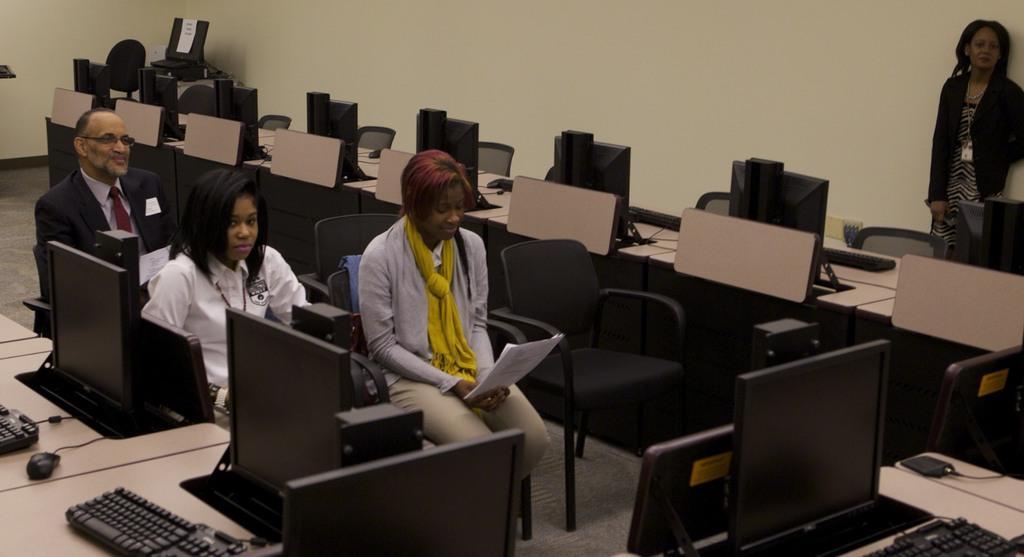Please provide a concise description of this image. This image is clicked inside a room. There are so many tables and monitors keyboards and mouses. There are so many chairs. 3 of them are sitting and one is star, standing. Woman sorry, 2 women are sitting and one man is sitting. One woman is holding paper in her hand, other woman is watching something. And the man is smiling. 